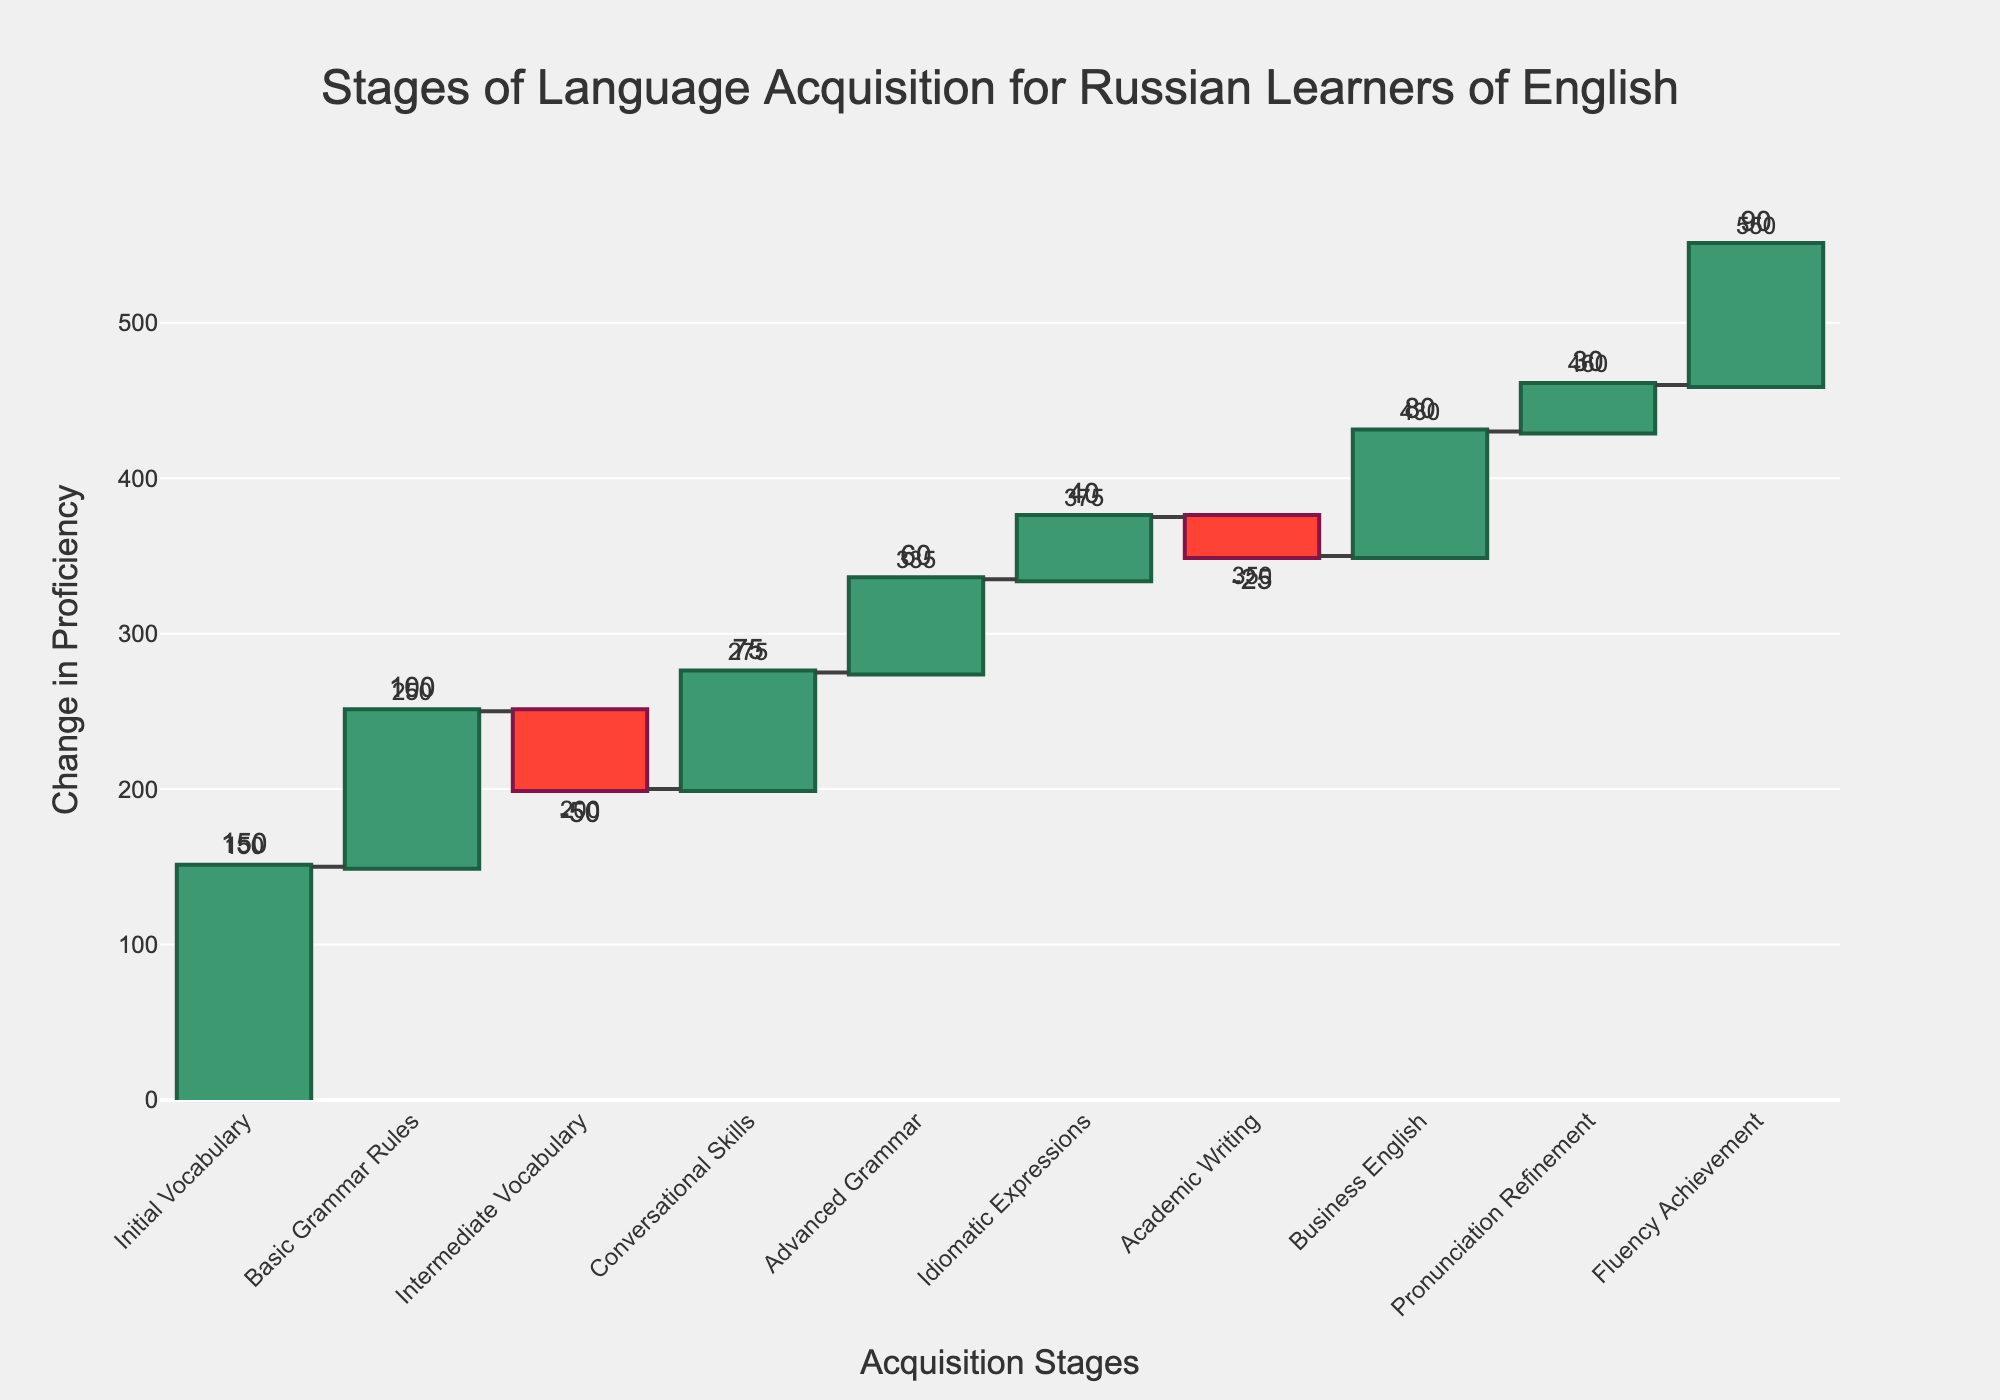What is the title of the chart? The chart title is usually positioned at the top center. It summarizes the content of the chart. In this case, it reads "Stages of Language Acquisition for Russian Learners of English".
Answer: "Stages of Language Acquisition for Russian Learners of English" How many stages are there in the language acquisition process? Count the number of unique stages listed on the x-axis of the chart. Each tick on the x-axis corresponds to a different stage, with names such as "Initial Vocabulary" and "Fluency Achievement". There are a total of 10 stages.
Answer: 10 Which stage shows the largest positive change in proficiency? Look for the stage with the highest value on the y-axis and the longest bar pointing upwards. In this case, "Fluency Achievement" has the highest positive change with a value of 90.
Answer: "Fluency Achievement" Which stage indicates a decrease in proficiency? Identify the bars that point downwards (in red). In this chart, "Intermediate Vocabulary" and "Academic Writing" both have negative changes in proficiency values.
Answer: "Intermediate Vocabulary" and "Academic Writing" What is the cumulative proficiency change after completing "Conversational Skills"? Sum the changes up to and including "Conversational Skills". The changes are: 150 + 100 - 50 + 75 = 275.
Answer: 275 What is the net change in proficiency from "Initial Vocabulary" to "Business English"? Calculate the sum of all changes from the "Initial Vocabulary" stage to the "Business English" stage. The changes are: 150 + 100 - 50 + 75 + 60 + 40 - 25 + 80 = 430.
Answer: 430 What is the total proficiency change across all stages? Sum up all the changes listed to find the total. The changes are: 150 + 100 - 50 + 75 + 60 + 40 - 25 + 80 + 30 + 90 = 550.
Answer: 550 Which stages have a positive change in proficiency? Identify all the stages with bars pointing upwards and whose values are positive on the y-axis. The stages are: "Initial Vocabulary", "Basic Grammar Rules", "Conversational Skills", "Advanced Grammar", "Idiomatic Expressions", "Business English", "Pronunciation Refinement", "Fluency Achievement".
Answer: "Initial Vocabulary", "Basic Grammar Rules", "Conversational Skills", "Advanced Grammar", "Idiomatic Expressions", "Business English", "Pronunciation Refinement", "Fluency Achievement" What stage follows "Intermediate Vocabulary"? To find out the stage immediately after "Intermediate Vocabulary", look at the x-axis labels. "Conversational Skills" follows "Intermediate Vocabulary".
Answer: "Conversational Skills" Between "Advanced Grammar" and "Pronunciation Refinement", which stage has a higher positive change in proficiency? Compare the values for "Advanced Grammar" (60) and "Pronunciation Refinement" (30). "Advanced Grammar" has a higher positive change.
Answer: "Advanced Grammar" 